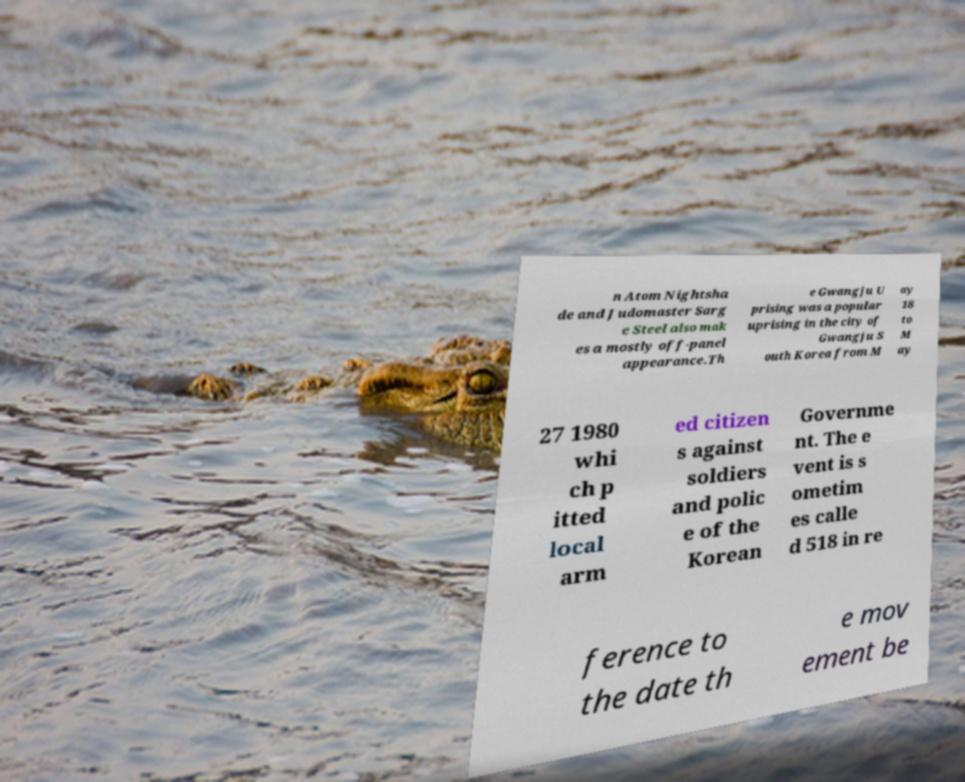Please identify and transcribe the text found in this image. n Atom Nightsha de and Judomaster Sarg e Steel also mak es a mostly off-panel appearance.Th e Gwangju U prising was a popular uprising in the city of Gwangju S outh Korea from M ay 18 to M ay 27 1980 whi ch p itted local arm ed citizen s against soldiers and polic e of the Korean Governme nt. The e vent is s ometim es calle d 518 in re ference to the date th e mov ement be 